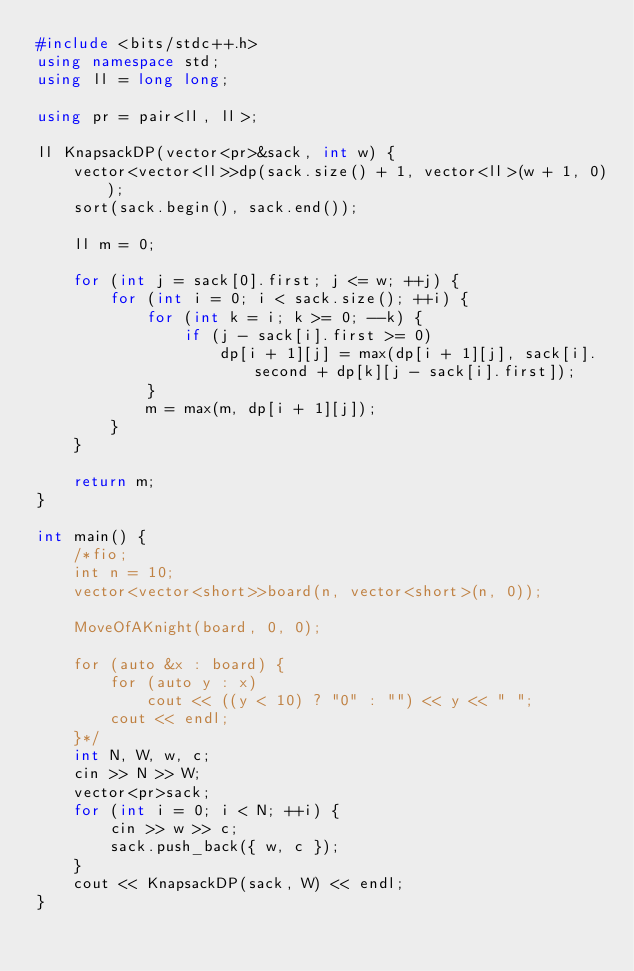<code> <loc_0><loc_0><loc_500><loc_500><_C++_>#include <bits/stdc++.h>
using namespace std;
using ll = long long;
 
using pr = pair<ll, ll>;
 
ll KnapsackDP(vector<pr>&sack, int w) {
	vector<vector<ll>>dp(sack.size() + 1, vector<ll>(w + 1, 0));
	sort(sack.begin(), sack.end());
 
	ll m = 0;
 
	for (int j = sack[0].first; j <= w; ++j) {
		for (int i = 0; i < sack.size(); ++i) {
			for (int k = i; k >= 0; --k) {
				if (j - sack[i].first >= 0)
					dp[i + 1][j] = max(dp[i + 1][j], sack[i].second + dp[k][j - sack[i].first]);
			}
			m = max(m, dp[i + 1][j]);
		}
	}
 
	return m;
}
 
int main() {
	/*fio;
	int n = 10;
	vector<vector<short>>board(n, vector<short>(n, 0));
 
	MoveOfAKnight(board, 0, 0);
 
	for (auto &x : board) {
		for (auto y : x)
			cout << ((y < 10) ? "0" : "") << y << " ";
		cout << endl;
	}*/
	int N, W, w, c;
	cin >> N >> W;
	vector<pr>sack;
	for (int i = 0; i < N; ++i) {
		cin >> w >> c;
		sack.push_back({ w, c });
	}
	cout << KnapsackDP(sack, W) << endl;
}</code> 